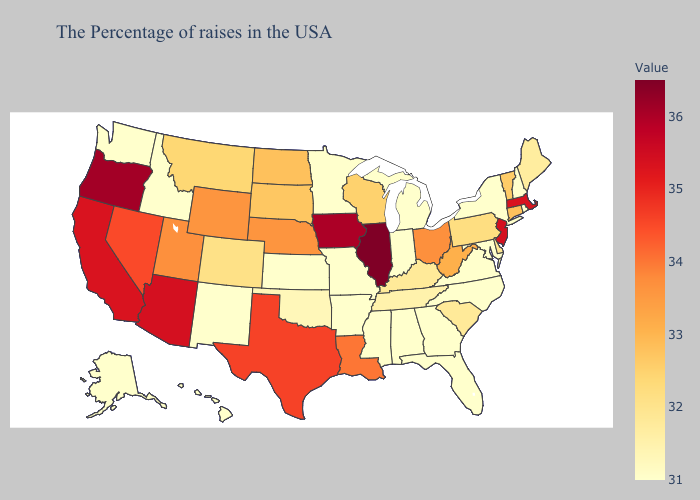Does Wyoming have the highest value in the West?
Keep it brief. No. Does Idaho have the lowest value in the USA?
Give a very brief answer. Yes. Among the states that border Indiana , does Michigan have the highest value?
Keep it brief. No. Among the states that border Colorado , does Kansas have the lowest value?
Concise answer only. Yes. Which states hav the highest value in the West?
Quick response, please. Oregon. Is the legend a continuous bar?
Be succinct. Yes. Which states hav the highest value in the Northeast?
Quick response, please. New Jersey. Which states have the lowest value in the West?
Answer briefly. New Mexico, Idaho, Washington, Alaska, Hawaii. 